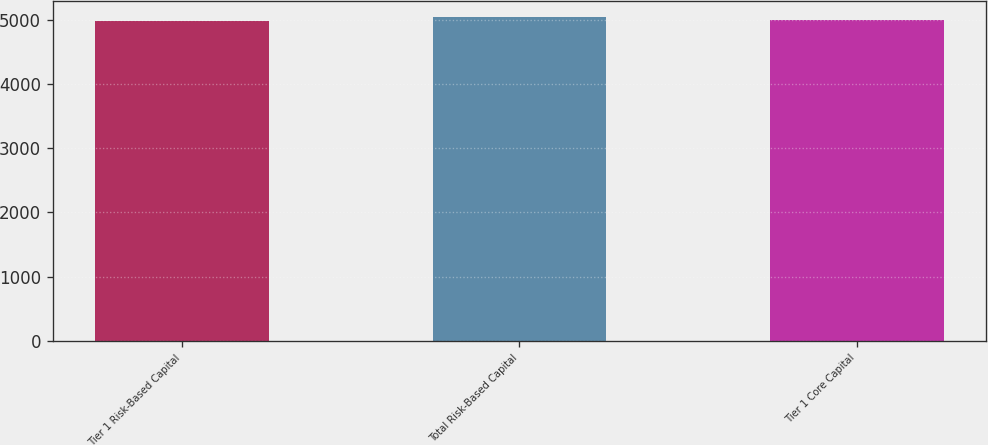Convert chart. <chart><loc_0><loc_0><loc_500><loc_500><bar_chart><fcel>Tier 1 Risk-Based Capital<fcel>Total Risk-Based Capital<fcel>Tier 1 Core Capital<nl><fcel>4984<fcel>5036<fcel>4989.2<nl></chart> 